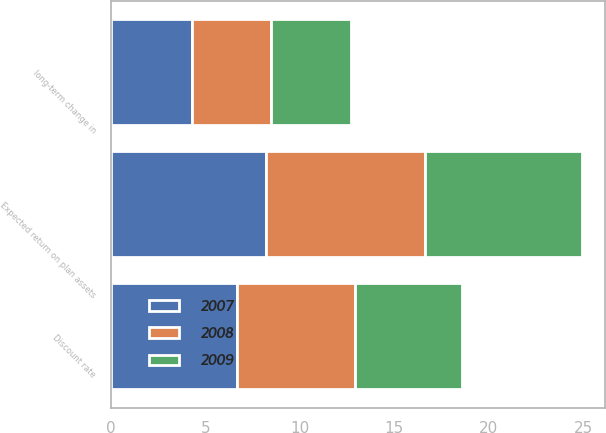<chart> <loc_0><loc_0><loc_500><loc_500><stacked_bar_chart><ecel><fcel>Discount rate<fcel>Expected return on plan assets<fcel>long-term change in<nl><fcel>2007<fcel>6.7<fcel>8.2<fcel>4.3<nl><fcel>2008<fcel>6.2<fcel>8.4<fcel>4.2<nl><fcel>2009<fcel>5.7<fcel>8.3<fcel>4.2<nl></chart> 